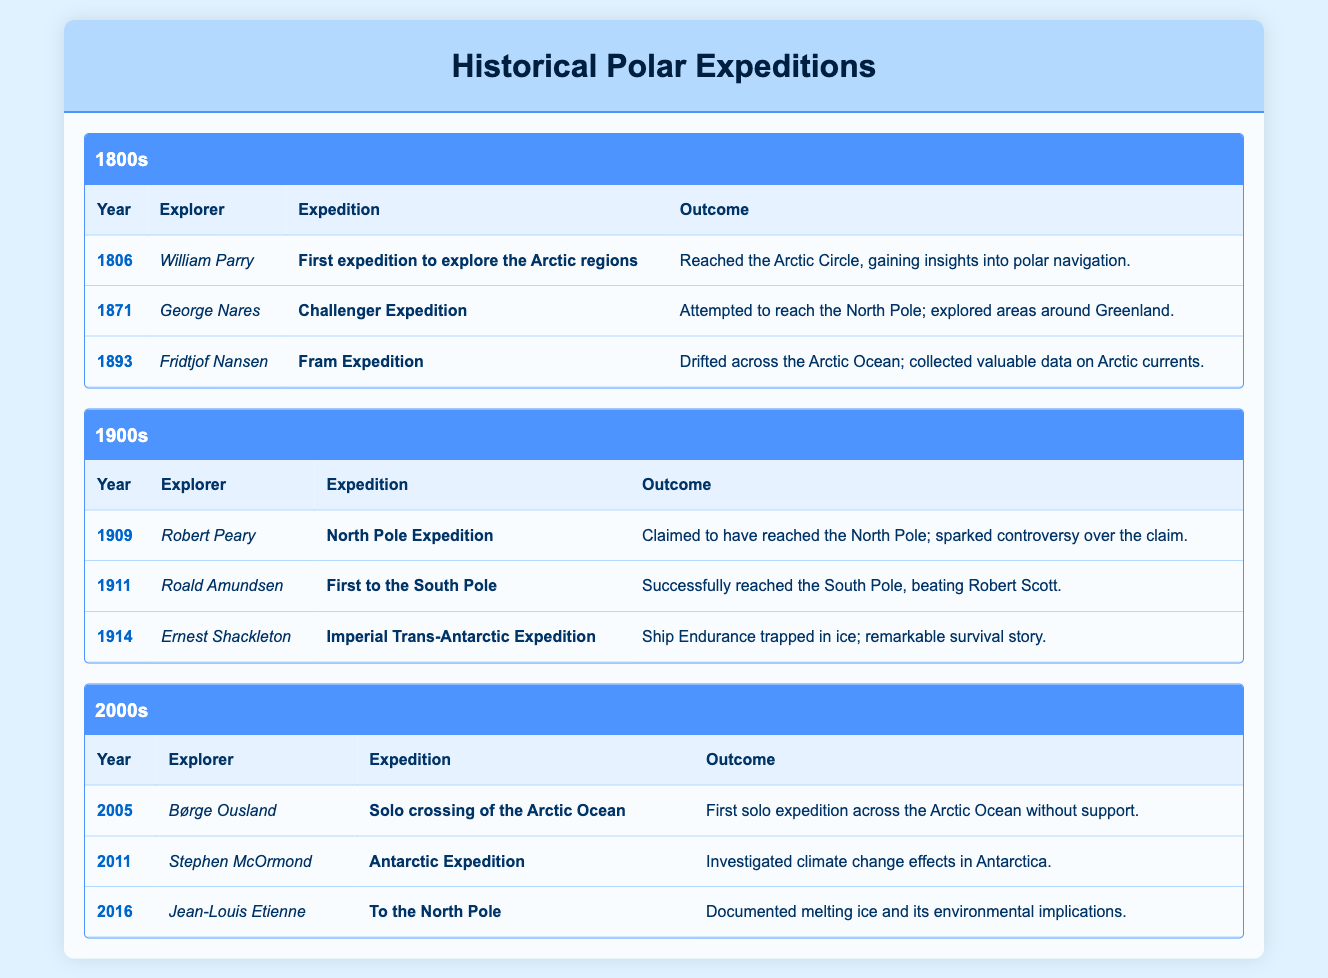What was the outcome of the Fram Expedition led by Fridtjof Nansen in 1893? The table indicates that the Fram Expedition drifted across the Arctic Ocean and collected valuable data on Arctic currents.
Answer: Drifted across the Arctic Ocean; collected valuable data on Arctic currents Who was the explorer of the Challenger Expedition in 1871? By looking at the 1871 row under the 1800s section of the table, we can see that George Nares was the explorer for the Challenger Expedition.
Answer: George Nares How many expeditions were conducted in the 2000s according to the table? Looking through the 2000s section, there are three expeditions listed: one by Børge Ousland in 2005, one by Stephen McOrmond in 2011, and one by Jean-Louis Etienne in 2016.
Answer: Three Was Robert Peary successful in his expedition to the North Pole in 1909? The table states that Robert Peary claimed to have reached the North Pole, but it also mentions that there was controversy over this claim, implying uncertainty about his success.
Answer: Yes, but controversial What was the expedition outcome of the Imperial Trans-Antarctic Expedition in 1914 led by Ernest Shackleton? The outcome listed for the Imperial Trans-Antarctic Expedition is that the ship Endurance was trapped in ice, which led to a remarkable survival story, reflecting a significant challenge faced during the expedition.
Answer: Ship Endurance trapped in ice; remarkable survival story Considering the explorers in the 1900s, who was the first to reach the South Pole, and what was the year? According to the table, Roald Amundsen was the first to reach the South Pole in 1911, as indicated in that row.
Answer: Roald Amundsen, 1911 What was the primary focus of Stephen McOrmond's Antarctic Expedition in 2011? The table shows that Stephen McOrmond's Antarctic Expedition focused on investigating climate change effects in Antarctica, citing ecological concerns.
Answer: Investigated climate change effects in Antarctica Which explorer's expedition provided valuable data on Arctic currents and in what year? Fridtjof Nansen's Fram Expedition in 1893 provided valuable data on Arctic currents, according to the table.
Answer: Fridtjof Nansen, 1893 How many expeditions in total focused on objectives related to climate change? The table indicates that Stephen McOrmond's Antarctic Expedition (2011) and Jean-Louis Etienne’s expedition (2016) both concerned climate change. Thus, there are two expeditions focusing on climate change objectives.
Answer: Two 